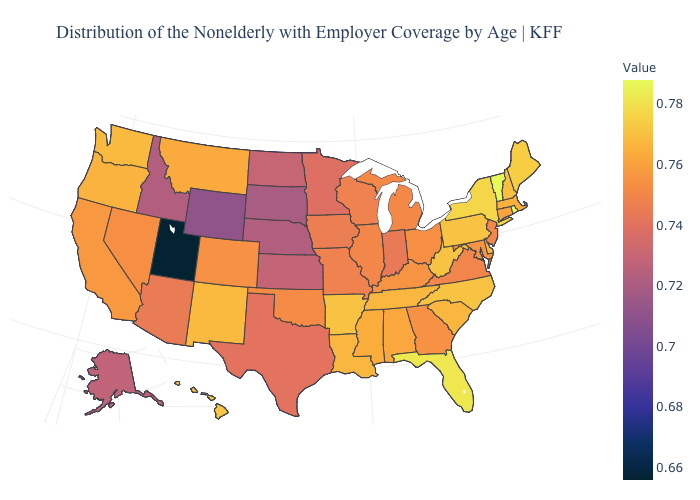Which states hav the highest value in the West?
Keep it brief. Hawaii. Does Louisiana have the highest value in the USA?
Concise answer only. No. Among the states that border Alabama , does Tennessee have the lowest value?
Give a very brief answer. No. Among the states that border Colorado , does Utah have the lowest value?
Answer briefly. Yes. 